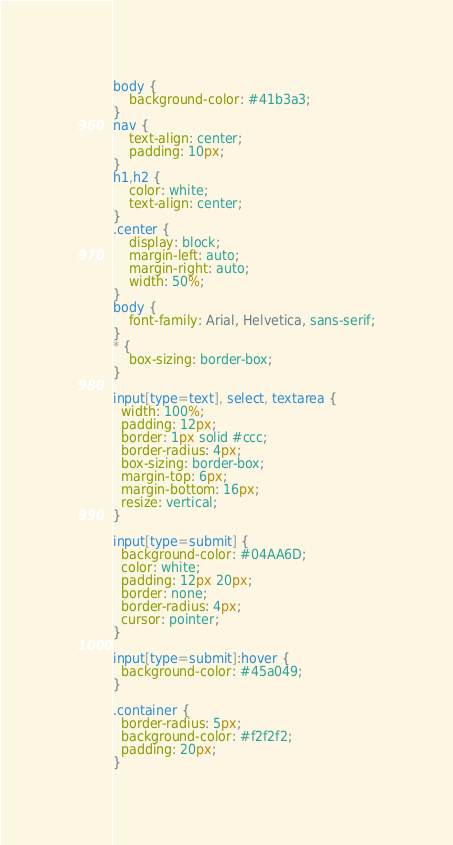<code> <loc_0><loc_0><loc_500><loc_500><_CSS_>body {
    background-color: #41b3a3;
}
nav {
    text-align: center;
    padding: 10px;
}
h1,h2 {
    color: white;
    text-align: center;
}
.center {
    display: block;
    margin-left: auto;
    margin-right: auto;
    width: 50%;
}
body {
    font-family: Arial, Helvetica, sans-serif;
}
* {
    box-sizing: border-box;
}

input[type=text], select, textarea {
  width: 100%;
  padding: 12px;
  border: 1px solid #ccc;
  border-radius: 4px;
  box-sizing: border-box;
  margin-top: 6px;
  margin-bottom: 16px;
  resize: vertical;
}

input[type=submit] {
  background-color: #04AA6D;
  color: white;
  padding: 12px 20px;
  border: none;
  border-radius: 4px;
  cursor: pointer;
}

input[type=submit]:hover {
  background-color: #45a049;
}

.container {
  border-radius: 5px;
  background-color: #f2f2f2;
  padding: 20px;
}</code> 